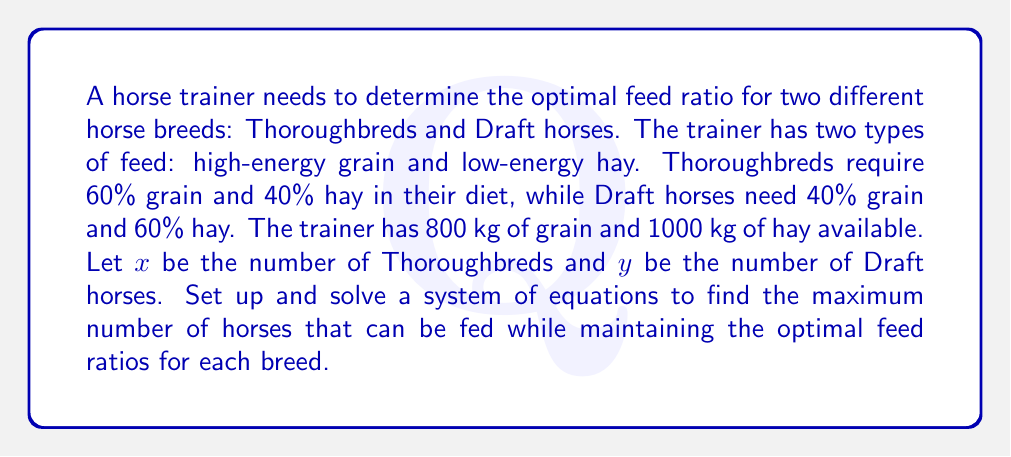Give your solution to this math problem. Let's approach this step-by-step:

1) First, we need to set up equations based on the grain and hay requirements:

   For grain: $0.6x + 0.4y \leq 800$
   For hay: $0.4x + 0.6y \leq 1000$

2) To maximize the number of horses, we want to use all available feed. So we change the inequalities to equalities:

   $0.6x + 0.4y = 800$
   $0.4x + 0.6y = 1000$

3) Now we have a system of two equations with two unknowns. We can solve this using substitution or elimination method. Let's use elimination:

4) Multiply the first equation by 2 and the second by 3:

   $1.2x + 0.8y = 1600$
   $1.2x + 1.8y = 3000$

5) Subtract the first equation from the second:

   $y = 1400$

6) Substitute this value of $y$ into the first equation:

   $0.6x + 0.4(1400) = 800$
   $0.6x = 800 - 560 = 240$
   $x = 400$

7) Therefore, the maximum number of horses that can be fed is:

   $400 + 1400 = 1800$

8) To verify, let's check if these numbers satisfy the original constraints:

   Grain: $0.6(400) + 0.4(1400) = 240 + 560 = 800$ kg (matches available grain)
   Hay: $0.4(400) + 0.6(1400) = 160 + 840 = 1000$ kg (matches available hay)
Answer: 400 Thoroughbreds and 1400 Draft horses 